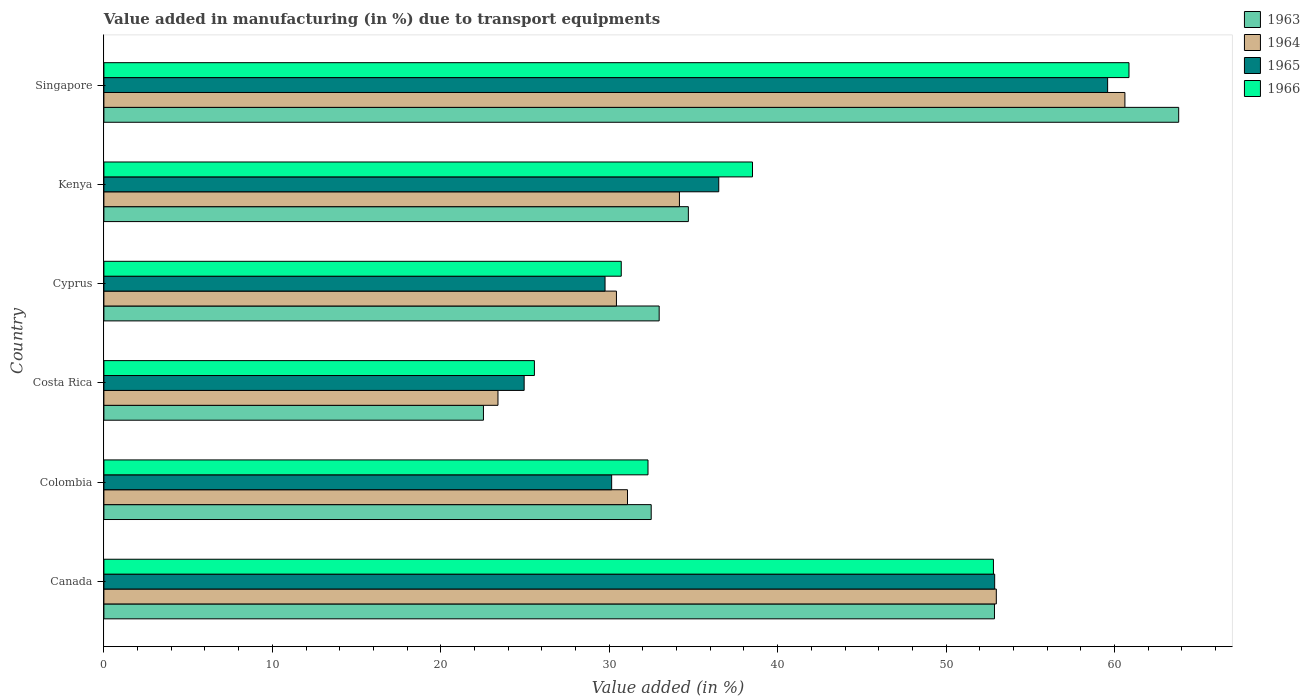How many different coloured bars are there?
Make the answer very short. 4. How many groups of bars are there?
Give a very brief answer. 6. Are the number of bars on each tick of the Y-axis equal?
Make the answer very short. Yes. How many bars are there on the 5th tick from the bottom?
Give a very brief answer. 4. What is the label of the 2nd group of bars from the top?
Your answer should be compact. Kenya. What is the percentage of value added in manufacturing due to transport equipments in 1966 in Singapore?
Ensure brevity in your answer.  60.86. Across all countries, what is the maximum percentage of value added in manufacturing due to transport equipments in 1963?
Your response must be concise. 63.81. Across all countries, what is the minimum percentage of value added in manufacturing due to transport equipments in 1963?
Make the answer very short. 22.53. In which country was the percentage of value added in manufacturing due to transport equipments in 1963 maximum?
Offer a very short reply. Singapore. In which country was the percentage of value added in manufacturing due to transport equipments in 1963 minimum?
Provide a short and direct response. Costa Rica. What is the total percentage of value added in manufacturing due to transport equipments in 1966 in the graph?
Provide a succinct answer. 240.76. What is the difference between the percentage of value added in manufacturing due to transport equipments in 1966 in Costa Rica and that in Cyprus?
Your response must be concise. -5.16. What is the difference between the percentage of value added in manufacturing due to transport equipments in 1964 in Singapore and the percentage of value added in manufacturing due to transport equipments in 1965 in Canada?
Offer a terse response. 7.73. What is the average percentage of value added in manufacturing due to transport equipments in 1963 per country?
Your response must be concise. 39.9. What is the difference between the percentage of value added in manufacturing due to transport equipments in 1963 and percentage of value added in manufacturing due to transport equipments in 1965 in Singapore?
Keep it short and to the point. 4.22. What is the ratio of the percentage of value added in manufacturing due to transport equipments in 1966 in Colombia to that in Cyprus?
Your answer should be very brief. 1.05. Is the percentage of value added in manufacturing due to transport equipments in 1965 in Costa Rica less than that in Cyprus?
Offer a terse response. Yes. Is the difference between the percentage of value added in manufacturing due to transport equipments in 1963 in Canada and Colombia greater than the difference between the percentage of value added in manufacturing due to transport equipments in 1965 in Canada and Colombia?
Your response must be concise. No. What is the difference between the highest and the second highest percentage of value added in manufacturing due to transport equipments in 1966?
Offer a very short reply. 8.05. What is the difference between the highest and the lowest percentage of value added in manufacturing due to transport equipments in 1963?
Ensure brevity in your answer.  41.28. What does the 3rd bar from the top in Singapore represents?
Your answer should be very brief. 1964. What does the 1st bar from the bottom in Singapore represents?
Keep it short and to the point. 1963. What is the difference between two consecutive major ticks on the X-axis?
Ensure brevity in your answer.  10. How are the legend labels stacked?
Make the answer very short. Vertical. What is the title of the graph?
Your response must be concise. Value added in manufacturing (in %) due to transport equipments. What is the label or title of the X-axis?
Keep it short and to the point. Value added (in %). What is the label or title of the Y-axis?
Give a very brief answer. Country. What is the Value added (in %) of 1963 in Canada?
Offer a very short reply. 52.87. What is the Value added (in %) of 1964 in Canada?
Offer a very short reply. 52.98. What is the Value added (in %) in 1965 in Canada?
Make the answer very short. 52.89. What is the Value added (in %) in 1966 in Canada?
Provide a short and direct response. 52.81. What is the Value added (in %) in 1963 in Colombia?
Make the answer very short. 32.49. What is the Value added (in %) in 1964 in Colombia?
Provide a succinct answer. 31.09. What is the Value added (in %) in 1965 in Colombia?
Ensure brevity in your answer.  30.15. What is the Value added (in %) in 1966 in Colombia?
Your response must be concise. 32.3. What is the Value added (in %) in 1963 in Costa Rica?
Give a very brief answer. 22.53. What is the Value added (in %) of 1964 in Costa Rica?
Provide a short and direct response. 23.4. What is the Value added (in %) of 1965 in Costa Rica?
Make the answer very short. 24.95. What is the Value added (in %) in 1966 in Costa Rica?
Keep it short and to the point. 25.56. What is the Value added (in %) in 1963 in Cyprus?
Ensure brevity in your answer.  32.97. What is the Value added (in %) in 1964 in Cyprus?
Offer a terse response. 30.43. What is the Value added (in %) in 1965 in Cyprus?
Offer a very short reply. 29.75. What is the Value added (in %) in 1966 in Cyprus?
Your answer should be very brief. 30.72. What is the Value added (in %) in 1963 in Kenya?
Make the answer very short. 34.7. What is the Value added (in %) in 1964 in Kenya?
Provide a succinct answer. 34.17. What is the Value added (in %) in 1965 in Kenya?
Offer a terse response. 36.5. What is the Value added (in %) of 1966 in Kenya?
Make the answer very short. 38.51. What is the Value added (in %) in 1963 in Singapore?
Offer a terse response. 63.81. What is the Value added (in %) of 1964 in Singapore?
Your answer should be very brief. 60.62. What is the Value added (in %) in 1965 in Singapore?
Keep it short and to the point. 59.59. What is the Value added (in %) of 1966 in Singapore?
Ensure brevity in your answer.  60.86. Across all countries, what is the maximum Value added (in %) of 1963?
Your response must be concise. 63.81. Across all countries, what is the maximum Value added (in %) in 1964?
Give a very brief answer. 60.62. Across all countries, what is the maximum Value added (in %) of 1965?
Make the answer very short. 59.59. Across all countries, what is the maximum Value added (in %) of 1966?
Provide a short and direct response. 60.86. Across all countries, what is the minimum Value added (in %) of 1963?
Provide a succinct answer. 22.53. Across all countries, what is the minimum Value added (in %) of 1964?
Your response must be concise. 23.4. Across all countries, what is the minimum Value added (in %) of 1965?
Your answer should be compact. 24.95. Across all countries, what is the minimum Value added (in %) of 1966?
Make the answer very short. 25.56. What is the total Value added (in %) of 1963 in the graph?
Your answer should be compact. 239.38. What is the total Value added (in %) in 1964 in the graph?
Your answer should be compact. 232.68. What is the total Value added (in %) in 1965 in the graph?
Ensure brevity in your answer.  233.83. What is the total Value added (in %) of 1966 in the graph?
Your response must be concise. 240.76. What is the difference between the Value added (in %) in 1963 in Canada and that in Colombia?
Offer a very short reply. 20.38. What is the difference between the Value added (in %) in 1964 in Canada and that in Colombia?
Ensure brevity in your answer.  21.9. What is the difference between the Value added (in %) in 1965 in Canada and that in Colombia?
Your response must be concise. 22.74. What is the difference between the Value added (in %) in 1966 in Canada and that in Colombia?
Give a very brief answer. 20.51. What is the difference between the Value added (in %) in 1963 in Canada and that in Costa Rica?
Make the answer very short. 30.34. What is the difference between the Value added (in %) of 1964 in Canada and that in Costa Rica?
Keep it short and to the point. 29.59. What is the difference between the Value added (in %) of 1965 in Canada and that in Costa Rica?
Offer a very short reply. 27.93. What is the difference between the Value added (in %) in 1966 in Canada and that in Costa Rica?
Offer a very short reply. 27.25. What is the difference between the Value added (in %) in 1963 in Canada and that in Cyprus?
Your answer should be compact. 19.91. What is the difference between the Value added (in %) in 1964 in Canada and that in Cyprus?
Ensure brevity in your answer.  22.55. What is the difference between the Value added (in %) in 1965 in Canada and that in Cyprus?
Your answer should be compact. 23.13. What is the difference between the Value added (in %) of 1966 in Canada and that in Cyprus?
Offer a very short reply. 22.1. What is the difference between the Value added (in %) in 1963 in Canada and that in Kenya?
Offer a very short reply. 18.17. What is the difference between the Value added (in %) in 1964 in Canada and that in Kenya?
Offer a terse response. 18.81. What is the difference between the Value added (in %) in 1965 in Canada and that in Kenya?
Provide a succinct answer. 16.38. What is the difference between the Value added (in %) of 1966 in Canada and that in Kenya?
Your response must be concise. 14.3. What is the difference between the Value added (in %) in 1963 in Canada and that in Singapore?
Offer a terse response. -10.94. What is the difference between the Value added (in %) of 1964 in Canada and that in Singapore?
Your response must be concise. -7.63. What is the difference between the Value added (in %) in 1965 in Canada and that in Singapore?
Your response must be concise. -6.71. What is the difference between the Value added (in %) in 1966 in Canada and that in Singapore?
Keep it short and to the point. -8.05. What is the difference between the Value added (in %) in 1963 in Colombia and that in Costa Rica?
Your response must be concise. 9.96. What is the difference between the Value added (in %) of 1964 in Colombia and that in Costa Rica?
Your answer should be compact. 7.69. What is the difference between the Value added (in %) in 1965 in Colombia and that in Costa Rica?
Keep it short and to the point. 5.2. What is the difference between the Value added (in %) in 1966 in Colombia and that in Costa Rica?
Offer a very short reply. 6.74. What is the difference between the Value added (in %) in 1963 in Colombia and that in Cyprus?
Provide a short and direct response. -0.47. What is the difference between the Value added (in %) of 1964 in Colombia and that in Cyprus?
Your answer should be very brief. 0.66. What is the difference between the Value added (in %) in 1965 in Colombia and that in Cyprus?
Keep it short and to the point. 0.39. What is the difference between the Value added (in %) in 1966 in Colombia and that in Cyprus?
Make the answer very short. 1.59. What is the difference between the Value added (in %) in 1963 in Colombia and that in Kenya?
Keep it short and to the point. -2.21. What is the difference between the Value added (in %) of 1964 in Colombia and that in Kenya?
Give a very brief answer. -3.08. What is the difference between the Value added (in %) in 1965 in Colombia and that in Kenya?
Provide a succinct answer. -6.36. What is the difference between the Value added (in %) in 1966 in Colombia and that in Kenya?
Ensure brevity in your answer.  -6.2. What is the difference between the Value added (in %) of 1963 in Colombia and that in Singapore?
Make the answer very short. -31.32. What is the difference between the Value added (in %) of 1964 in Colombia and that in Singapore?
Your response must be concise. -29.53. What is the difference between the Value added (in %) of 1965 in Colombia and that in Singapore?
Ensure brevity in your answer.  -29.45. What is the difference between the Value added (in %) of 1966 in Colombia and that in Singapore?
Provide a short and direct response. -28.56. What is the difference between the Value added (in %) in 1963 in Costa Rica and that in Cyprus?
Provide a short and direct response. -10.43. What is the difference between the Value added (in %) in 1964 in Costa Rica and that in Cyprus?
Your response must be concise. -7.03. What is the difference between the Value added (in %) in 1965 in Costa Rica and that in Cyprus?
Give a very brief answer. -4.8. What is the difference between the Value added (in %) of 1966 in Costa Rica and that in Cyprus?
Offer a terse response. -5.16. What is the difference between the Value added (in %) in 1963 in Costa Rica and that in Kenya?
Provide a short and direct response. -12.17. What is the difference between the Value added (in %) in 1964 in Costa Rica and that in Kenya?
Provide a short and direct response. -10.77. What is the difference between the Value added (in %) of 1965 in Costa Rica and that in Kenya?
Your answer should be very brief. -11.55. What is the difference between the Value added (in %) in 1966 in Costa Rica and that in Kenya?
Give a very brief answer. -12.95. What is the difference between the Value added (in %) of 1963 in Costa Rica and that in Singapore?
Your answer should be very brief. -41.28. What is the difference between the Value added (in %) in 1964 in Costa Rica and that in Singapore?
Provide a succinct answer. -37.22. What is the difference between the Value added (in %) in 1965 in Costa Rica and that in Singapore?
Offer a very short reply. -34.64. What is the difference between the Value added (in %) in 1966 in Costa Rica and that in Singapore?
Your answer should be very brief. -35.3. What is the difference between the Value added (in %) in 1963 in Cyprus and that in Kenya?
Your response must be concise. -1.73. What is the difference between the Value added (in %) of 1964 in Cyprus and that in Kenya?
Your response must be concise. -3.74. What is the difference between the Value added (in %) of 1965 in Cyprus and that in Kenya?
Your answer should be compact. -6.75. What is the difference between the Value added (in %) in 1966 in Cyprus and that in Kenya?
Ensure brevity in your answer.  -7.79. What is the difference between the Value added (in %) in 1963 in Cyprus and that in Singapore?
Your answer should be very brief. -30.84. What is the difference between the Value added (in %) of 1964 in Cyprus and that in Singapore?
Your answer should be compact. -30.19. What is the difference between the Value added (in %) of 1965 in Cyprus and that in Singapore?
Your answer should be very brief. -29.84. What is the difference between the Value added (in %) in 1966 in Cyprus and that in Singapore?
Offer a very short reply. -30.14. What is the difference between the Value added (in %) of 1963 in Kenya and that in Singapore?
Offer a terse response. -29.11. What is the difference between the Value added (in %) in 1964 in Kenya and that in Singapore?
Make the answer very short. -26.45. What is the difference between the Value added (in %) in 1965 in Kenya and that in Singapore?
Keep it short and to the point. -23.09. What is the difference between the Value added (in %) of 1966 in Kenya and that in Singapore?
Keep it short and to the point. -22.35. What is the difference between the Value added (in %) of 1963 in Canada and the Value added (in %) of 1964 in Colombia?
Provide a short and direct response. 21.79. What is the difference between the Value added (in %) of 1963 in Canada and the Value added (in %) of 1965 in Colombia?
Keep it short and to the point. 22.73. What is the difference between the Value added (in %) in 1963 in Canada and the Value added (in %) in 1966 in Colombia?
Make the answer very short. 20.57. What is the difference between the Value added (in %) in 1964 in Canada and the Value added (in %) in 1965 in Colombia?
Make the answer very short. 22.84. What is the difference between the Value added (in %) in 1964 in Canada and the Value added (in %) in 1966 in Colombia?
Offer a very short reply. 20.68. What is the difference between the Value added (in %) in 1965 in Canada and the Value added (in %) in 1966 in Colombia?
Keep it short and to the point. 20.58. What is the difference between the Value added (in %) of 1963 in Canada and the Value added (in %) of 1964 in Costa Rica?
Your answer should be compact. 29.48. What is the difference between the Value added (in %) in 1963 in Canada and the Value added (in %) in 1965 in Costa Rica?
Make the answer very short. 27.92. What is the difference between the Value added (in %) in 1963 in Canada and the Value added (in %) in 1966 in Costa Rica?
Provide a short and direct response. 27.31. What is the difference between the Value added (in %) in 1964 in Canada and the Value added (in %) in 1965 in Costa Rica?
Your answer should be very brief. 28.03. What is the difference between the Value added (in %) of 1964 in Canada and the Value added (in %) of 1966 in Costa Rica?
Make the answer very short. 27.42. What is the difference between the Value added (in %) in 1965 in Canada and the Value added (in %) in 1966 in Costa Rica?
Offer a terse response. 27.33. What is the difference between the Value added (in %) of 1963 in Canada and the Value added (in %) of 1964 in Cyprus?
Offer a very short reply. 22.44. What is the difference between the Value added (in %) of 1963 in Canada and the Value added (in %) of 1965 in Cyprus?
Your answer should be very brief. 23.12. What is the difference between the Value added (in %) in 1963 in Canada and the Value added (in %) in 1966 in Cyprus?
Give a very brief answer. 22.16. What is the difference between the Value added (in %) in 1964 in Canada and the Value added (in %) in 1965 in Cyprus?
Make the answer very short. 23.23. What is the difference between the Value added (in %) of 1964 in Canada and the Value added (in %) of 1966 in Cyprus?
Make the answer very short. 22.27. What is the difference between the Value added (in %) in 1965 in Canada and the Value added (in %) in 1966 in Cyprus?
Give a very brief answer. 22.17. What is the difference between the Value added (in %) of 1963 in Canada and the Value added (in %) of 1964 in Kenya?
Ensure brevity in your answer.  18.7. What is the difference between the Value added (in %) of 1963 in Canada and the Value added (in %) of 1965 in Kenya?
Provide a succinct answer. 16.37. What is the difference between the Value added (in %) in 1963 in Canada and the Value added (in %) in 1966 in Kenya?
Offer a very short reply. 14.37. What is the difference between the Value added (in %) of 1964 in Canada and the Value added (in %) of 1965 in Kenya?
Make the answer very short. 16.48. What is the difference between the Value added (in %) of 1964 in Canada and the Value added (in %) of 1966 in Kenya?
Provide a succinct answer. 14.47. What is the difference between the Value added (in %) of 1965 in Canada and the Value added (in %) of 1966 in Kenya?
Provide a succinct answer. 14.38. What is the difference between the Value added (in %) in 1963 in Canada and the Value added (in %) in 1964 in Singapore?
Your answer should be compact. -7.74. What is the difference between the Value added (in %) in 1963 in Canada and the Value added (in %) in 1965 in Singapore?
Provide a short and direct response. -6.72. What is the difference between the Value added (in %) of 1963 in Canada and the Value added (in %) of 1966 in Singapore?
Offer a terse response. -7.99. What is the difference between the Value added (in %) of 1964 in Canada and the Value added (in %) of 1965 in Singapore?
Provide a succinct answer. -6.61. What is the difference between the Value added (in %) of 1964 in Canada and the Value added (in %) of 1966 in Singapore?
Give a very brief answer. -7.88. What is the difference between the Value added (in %) of 1965 in Canada and the Value added (in %) of 1966 in Singapore?
Make the answer very short. -7.97. What is the difference between the Value added (in %) in 1963 in Colombia and the Value added (in %) in 1964 in Costa Rica?
Offer a terse response. 9.1. What is the difference between the Value added (in %) of 1963 in Colombia and the Value added (in %) of 1965 in Costa Rica?
Give a very brief answer. 7.54. What is the difference between the Value added (in %) of 1963 in Colombia and the Value added (in %) of 1966 in Costa Rica?
Your answer should be very brief. 6.93. What is the difference between the Value added (in %) in 1964 in Colombia and the Value added (in %) in 1965 in Costa Rica?
Ensure brevity in your answer.  6.14. What is the difference between the Value added (in %) in 1964 in Colombia and the Value added (in %) in 1966 in Costa Rica?
Offer a terse response. 5.53. What is the difference between the Value added (in %) of 1965 in Colombia and the Value added (in %) of 1966 in Costa Rica?
Provide a short and direct response. 4.59. What is the difference between the Value added (in %) of 1963 in Colombia and the Value added (in %) of 1964 in Cyprus?
Your response must be concise. 2.06. What is the difference between the Value added (in %) of 1963 in Colombia and the Value added (in %) of 1965 in Cyprus?
Your response must be concise. 2.74. What is the difference between the Value added (in %) of 1963 in Colombia and the Value added (in %) of 1966 in Cyprus?
Provide a short and direct response. 1.78. What is the difference between the Value added (in %) in 1964 in Colombia and the Value added (in %) in 1965 in Cyprus?
Your response must be concise. 1.33. What is the difference between the Value added (in %) in 1964 in Colombia and the Value added (in %) in 1966 in Cyprus?
Your response must be concise. 0.37. What is the difference between the Value added (in %) of 1965 in Colombia and the Value added (in %) of 1966 in Cyprus?
Keep it short and to the point. -0.57. What is the difference between the Value added (in %) in 1963 in Colombia and the Value added (in %) in 1964 in Kenya?
Provide a short and direct response. -1.68. What is the difference between the Value added (in %) in 1963 in Colombia and the Value added (in %) in 1965 in Kenya?
Provide a short and direct response. -4.01. What is the difference between the Value added (in %) of 1963 in Colombia and the Value added (in %) of 1966 in Kenya?
Your response must be concise. -6.01. What is the difference between the Value added (in %) in 1964 in Colombia and the Value added (in %) in 1965 in Kenya?
Make the answer very short. -5.42. What is the difference between the Value added (in %) of 1964 in Colombia and the Value added (in %) of 1966 in Kenya?
Ensure brevity in your answer.  -7.42. What is the difference between the Value added (in %) in 1965 in Colombia and the Value added (in %) in 1966 in Kenya?
Ensure brevity in your answer.  -8.36. What is the difference between the Value added (in %) in 1963 in Colombia and the Value added (in %) in 1964 in Singapore?
Your response must be concise. -28.12. What is the difference between the Value added (in %) of 1963 in Colombia and the Value added (in %) of 1965 in Singapore?
Ensure brevity in your answer.  -27.1. What is the difference between the Value added (in %) of 1963 in Colombia and the Value added (in %) of 1966 in Singapore?
Your answer should be compact. -28.37. What is the difference between the Value added (in %) in 1964 in Colombia and the Value added (in %) in 1965 in Singapore?
Give a very brief answer. -28.51. What is the difference between the Value added (in %) in 1964 in Colombia and the Value added (in %) in 1966 in Singapore?
Offer a terse response. -29.77. What is the difference between the Value added (in %) in 1965 in Colombia and the Value added (in %) in 1966 in Singapore?
Give a very brief answer. -30.71. What is the difference between the Value added (in %) in 1963 in Costa Rica and the Value added (in %) in 1964 in Cyprus?
Provide a succinct answer. -7.9. What is the difference between the Value added (in %) of 1963 in Costa Rica and the Value added (in %) of 1965 in Cyprus?
Offer a terse response. -7.22. What is the difference between the Value added (in %) in 1963 in Costa Rica and the Value added (in %) in 1966 in Cyprus?
Your answer should be compact. -8.18. What is the difference between the Value added (in %) in 1964 in Costa Rica and the Value added (in %) in 1965 in Cyprus?
Offer a terse response. -6.36. What is the difference between the Value added (in %) of 1964 in Costa Rica and the Value added (in %) of 1966 in Cyprus?
Offer a terse response. -7.32. What is the difference between the Value added (in %) of 1965 in Costa Rica and the Value added (in %) of 1966 in Cyprus?
Make the answer very short. -5.77. What is the difference between the Value added (in %) of 1963 in Costa Rica and the Value added (in %) of 1964 in Kenya?
Offer a very short reply. -11.64. What is the difference between the Value added (in %) in 1963 in Costa Rica and the Value added (in %) in 1965 in Kenya?
Your answer should be very brief. -13.97. What is the difference between the Value added (in %) of 1963 in Costa Rica and the Value added (in %) of 1966 in Kenya?
Provide a succinct answer. -15.97. What is the difference between the Value added (in %) of 1964 in Costa Rica and the Value added (in %) of 1965 in Kenya?
Ensure brevity in your answer.  -13.11. What is the difference between the Value added (in %) of 1964 in Costa Rica and the Value added (in %) of 1966 in Kenya?
Offer a very short reply. -15.11. What is the difference between the Value added (in %) of 1965 in Costa Rica and the Value added (in %) of 1966 in Kenya?
Your answer should be very brief. -13.56. What is the difference between the Value added (in %) of 1963 in Costa Rica and the Value added (in %) of 1964 in Singapore?
Offer a very short reply. -38.08. What is the difference between the Value added (in %) of 1963 in Costa Rica and the Value added (in %) of 1965 in Singapore?
Give a very brief answer. -37.06. What is the difference between the Value added (in %) in 1963 in Costa Rica and the Value added (in %) in 1966 in Singapore?
Ensure brevity in your answer.  -38.33. What is the difference between the Value added (in %) of 1964 in Costa Rica and the Value added (in %) of 1965 in Singapore?
Provide a short and direct response. -36.19. What is the difference between the Value added (in %) in 1964 in Costa Rica and the Value added (in %) in 1966 in Singapore?
Offer a terse response. -37.46. What is the difference between the Value added (in %) of 1965 in Costa Rica and the Value added (in %) of 1966 in Singapore?
Give a very brief answer. -35.91. What is the difference between the Value added (in %) of 1963 in Cyprus and the Value added (in %) of 1964 in Kenya?
Offer a very short reply. -1.2. What is the difference between the Value added (in %) of 1963 in Cyprus and the Value added (in %) of 1965 in Kenya?
Give a very brief answer. -3.54. What is the difference between the Value added (in %) of 1963 in Cyprus and the Value added (in %) of 1966 in Kenya?
Your response must be concise. -5.54. What is the difference between the Value added (in %) in 1964 in Cyprus and the Value added (in %) in 1965 in Kenya?
Keep it short and to the point. -6.07. What is the difference between the Value added (in %) of 1964 in Cyprus and the Value added (in %) of 1966 in Kenya?
Offer a very short reply. -8.08. What is the difference between the Value added (in %) in 1965 in Cyprus and the Value added (in %) in 1966 in Kenya?
Make the answer very short. -8.75. What is the difference between the Value added (in %) in 1963 in Cyprus and the Value added (in %) in 1964 in Singapore?
Provide a succinct answer. -27.65. What is the difference between the Value added (in %) of 1963 in Cyprus and the Value added (in %) of 1965 in Singapore?
Your answer should be very brief. -26.62. What is the difference between the Value added (in %) of 1963 in Cyprus and the Value added (in %) of 1966 in Singapore?
Give a very brief answer. -27.89. What is the difference between the Value added (in %) of 1964 in Cyprus and the Value added (in %) of 1965 in Singapore?
Ensure brevity in your answer.  -29.16. What is the difference between the Value added (in %) in 1964 in Cyprus and the Value added (in %) in 1966 in Singapore?
Offer a very short reply. -30.43. What is the difference between the Value added (in %) of 1965 in Cyprus and the Value added (in %) of 1966 in Singapore?
Provide a succinct answer. -31.11. What is the difference between the Value added (in %) of 1963 in Kenya and the Value added (in %) of 1964 in Singapore?
Your answer should be compact. -25.92. What is the difference between the Value added (in %) of 1963 in Kenya and the Value added (in %) of 1965 in Singapore?
Provide a short and direct response. -24.89. What is the difference between the Value added (in %) of 1963 in Kenya and the Value added (in %) of 1966 in Singapore?
Keep it short and to the point. -26.16. What is the difference between the Value added (in %) in 1964 in Kenya and the Value added (in %) in 1965 in Singapore?
Your response must be concise. -25.42. What is the difference between the Value added (in %) in 1964 in Kenya and the Value added (in %) in 1966 in Singapore?
Your answer should be compact. -26.69. What is the difference between the Value added (in %) of 1965 in Kenya and the Value added (in %) of 1966 in Singapore?
Your response must be concise. -24.36. What is the average Value added (in %) in 1963 per country?
Make the answer very short. 39.9. What is the average Value added (in %) in 1964 per country?
Offer a terse response. 38.78. What is the average Value added (in %) of 1965 per country?
Your answer should be very brief. 38.97. What is the average Value added (in %) of 1966 per country?
Make the answer very short. 40.13. What is the difference between the Value added (in %) in 1963 and Value added (in %) in 1964 in Canada?
Make the answer very short. -0.11. What is the difference between the Value added (in %) of 1963 and Value added (in %) of 1965 in Canada?
Your answer should be compact. -0.01. What is the difference between the Value added (in %) of 1963 and Value added (in %) of 1966 in Canada?
Keep it short and to the point. 0.06. What is the difference between the Value added (in %) in 1964 and Value added (in %) in 1965 in Canada?
Provide a succinct answer. 0.1. What is the difference between the Value added (in %) of 1964 and Value added (in %) of 1966 in Canada?
Your answer should be very brief. 0.17. What is the difference between the Value added (in %) of 1965 and Value added (in %) of 1966 in Canada?
Provide a succinct answer. 0.07. What is the difference between the Value added (in %) of 1963 and Value added (in %) of 1964 in Colombia?
Your answer should be compact. 1.41. What is the difference between the Value added (in %) of 1963 and Value added (in %) of 1965 in Colombia?
Give a very brief answer. 2.35. What is the difference between the Value added (in %) of 1963 and Value added (in %) of 1966 in Colombia?
Give a very brief answer. 0.19. What is the difference between the Value added (in %) in 1964 and Value added (in %) in 1965 in Colombia?
Your response must be concise. 0.94. What is the difference between the Value added (in %) in 1964 and Value added (in %) in 1966 in Colombia?
Give a very brief answer. -1.22. What is the difference between the Value added (in %) in 1965 and Value added (in %) in 1966 in Colombia?
Your response must be concise. -2.16. What is the difference between the Value added (in %) of 1963 and Value added (in %) of 1964 in Costa Rica?
Keep it short and to the point. -0.86. What is the difference between the Value added (in %) of 1963 and Value added (in %) of 1965 in Costa Rica?
Give a very brief answer. -2.42. What is the difference between the Value added (in %) in 1963 and Value added (in %) in 1966 in Costa Rica?
Keep it short and to the point. -3.03. What is the difference between the Value added (in %) of 1964 and Value added (in %) of 1965 in Costa Rica?
Provide a succinct answer. -1.55. What is the difference between the Value added (in %) of 1964 and Value added (in %) of 1966 in Costa Rica?
Provide a short and direct response. -2.16. What is the difference between the Value added (in %) in 1965 and Value added (in %) in 1966 in Costa Rica?
Keep it short and to the point. -0.61. What is the difference between the Value added (in %) in 1963 and Value added (in %) in 1964 in Cyprus?
Your answer should be compact. 2.54. What is the difference between the Value added (in %) in 1963 and Value added (in %) in 1965 in Cyprus?
Keep it short and to the point. 3.21. What is the difference between the Value added (in %) in 1963 and Value added (in %) in 1966 in Cyprus?
Provide a succinct answer. 2.25. What is the difference between the Value added (in %) of 1964 and Value added (in %) of 1965 in Cyprus?
Provide a short and direct response. 0.68. What is the difference between the Value added (in %) of 1964 and Value added (in %) of 1966 in Cyprus?
Offer a very short reply. -0.29. What is the difference between the Value added (in %) of 1965 and Value added (in %) of 1966 in Cyprus?
Offer a very short reply. -0.96. What is the difference between the Value added (in %) of 1963 and Value added (in %) of 1964 in Kenya?
Keep it short and to the point. 0.53. What is the difference between the Value added (in %) in 1963 and Value added (in %) in 1965 in Kenya?
Ensure brevity in your answer.  -1.8. What is the difference between the Value added (in %) in 1963 and Value added (in %) in 1966 in Kenya?
Provide a succinct answer. -3.81. What is the difference between the Value added (in %) of 1964 and Value added (in %) of 1965 in Kenya?
Provide a succinct answer. -2.33. What is the difference between the Value added (in %) of 1964 and Value added (in %) of 1966 in Kenya?
Offer a terse response. -4.34. What is the difference between the Value added (in %) of 1965 and Value added (in %) of 1966 in Kenya?
Make the answer very short. -2. What is the difference between the Value added (in %) of 1963 and Value added (in %) of 1964 in Singapore?
Give a very brief answer. 3.19. What is the difference between the Value added (in %) of 1963 and Value added (in %) of 1965 in Singapore?
Your answer should be compact. 4.22. What is the difference between the Value added (in %) in 1963 and Value added (in %) in 1966 in Singapore?
Your answer should be compact. 2.95. What is the difference between the Value added (in %) of 1964 and Value added (in %) of 1965 in Singapore?
Your answer should be compact. 1.03. What is the difference between the Value added (in %) in 1964 and Value added (in %) in 1966 in Singapore?
Provide a short and direct response. -0.24. What is the difference between the Value added (in %) in 1965 and Value added (in %) in 1966 in Singapore?
Provide a short and direct response. -1.27. What is the ratio of the Value added (in %) of 1963 in Canada to that in Colombia?
Offer a terse response. 1.63. What is the ratio of the Value added (in %) in 1964 in Canada to that in Colombia?
Ensure brevity in your answer.  1.7. What is the ratio of the Value added (in %) of 1965 in Canada to that in Colombia?
Make the answer very short. 1.75. What is the ratio of the Value added (in %) in 1966 in Canada to that in Colombia?
Your response must be concise. 1.63. What is the ratio of the Value added (in %) in 1963 in Canada to that in Costa Rica?
Ensure brevity in your answer.  2.35. What is the ratio of the Value added (in %) in 1964 in Canada to that in Costa Rica?
Keep it short and to the point. 2.26. What is the ratio of the Value added (in %) in 1965 in Canada to that in Costa Rica?
Ensure brevity in your answer.  2.12. What is the ratio of the Value added (in %) of 1966 in Canada to that in Costa Rica?
Make the answer very short. 2.07. What is the ratio of the Value added (in %) in 1963 in Canada to that in Cyprus?
Your response must be concise. 1.6. What is the ratio of the Value added (in %) of 1964 in Canada to that in Cyprus?
Your answer should be compact. 1.74. What is the ratio of the Value added (in %) in 1965 in Canada to that in Cyprus?
Make the answer very short. 1.78. What is the ratio of the Value added (in %) in 1966 in Canada to that in Cyprus?
Offer a very short reply. 1.72. What is the ratio of the Value added (in %) in 1963 in Canada to that in Kenya?
Your answer should be very brief. 1.52. What is the ratio of the Value added (in %) of 1964 in Canada to that in Kenya?
Give a very brief answer. 1.55. What is the ratio of the Value added (in %) of 1965 in Canada to that in Kenya?
Keep it short and to the point. 1.45. What is the ratio of the Value added (in %) of 1966 in Canada to that in Kenya?
Provide a short and direct response. 1.37. What is the ratio of the Value added (in %) of 1963 in Canada to that in Singapore?
Your response must be concise. 0.83. What is the ratio of the Value added (in %) of 1964 in Canada to that in Singapore?
Your response must be concise. 0.87. What is the ratio of the Value added (in %) of 1965 in Canada to that in Singapore?
Your response must be concise. 0.89. What is the ratio of the Value added (in %) in 1966 in Canada to that in Singapore?
Offer a very short reply. 0.87. What is the ratio of the Value added (in %) of 1963 in Colombia to that in Costa Rica?
Offer a very short reply. 1.44. What is the ratio of the Value added (in %) of 1964 in Colombia to that in Costa Rica?
Ensure brevity in your answer.  1.33. What is the ratio of the Value added (in %) in 1965 in Colombia to that in Costa Rica?
Keep it short and to the point. 1.21. What is the ratio of the Value added (in %) in 1966 in Colombia to that in Costa Rica?
Offer a terse response. 1.26. What is the ratio of the Value added (in %) in 1963 in Colombia to that in Cyprus?
Keep it short and to the point. 0.99. What is the ratio of the Value added (in %) of 1964 in Colombia to that in Cyprus?
Your response must be concise. 1.02. What is the ratio of the Value added (in %) in 1965 in Colombia to that in Cyprus?
Provide a short and direct response. 1.01. What is the ratio of the Value added (in %) of 1966 in Colombia to that in Cyprus?
Provide a succinct answer. 1.05. What is the ratio of the Value added (in %) in 1963 in Colombia to that in Kenya?
Ensure brevity in your answer.  0.94. What is the ratio of the Value added (in %) of 1964 in Colombia to that in Kenya?
Your answer should be compact. 0.91. What is the ratio of the Value added (in %) of 1965 in Colombia to that in Kenya?
Offer a terse response. 0.83. What is the ratio of the Value added (in %) of 1966 in Colombia to that in Kenya?
Your answer should be compact. 0.84. What is the ratio of the Value added (in %) in 1963 in Colombia to that in Singapore?
Give a very brief answer. 0.51. What is the ratio of the Value added (in %) of 1964 in Colombia to that in Singapore?
Your response must be concise. 0.51. What is the ratio of the Value added (in %) of 1965 in Colombia to that in Singapore?
Offer a terse response. 0.51. What is the ratio of the Value added (in %) of 1966 in Colombia to that in Singapore?
Provide a succinct answer. 0.53. What is the ratio of the Value added (in %) in 1963 in Costa Rica to that in Cyprus?
Keep it short and to the point. 0.68. What is the ratio of the Value added (in %) of 1964 in Costa Rica to that in Cyprus?
Give a very brief answer. 0.77. What is the ratio of the Value added (in %) of 1965 in Costa Rica to that in Cyprus?
Your answer should be compact. 0.84. What is the ratio of the Value added (in %) in 1966 in Costa Rica to that in Cyprus?
Make the answer very short. 0.83. What is the ratio of the Value added (in %) in 1963 in Costa Rica to that in Kenya?
Offer a terse response. 0.65. What is the ratio of the Value added (in %) of 1964 in Costa Rica to that in Kenya?
Your answer should be very brief. 0.68. What is the ratio of the Value added (in %) in 1965 in Costa Rica to that in Kenya?
Offer a terse response. 0.68. What is the ratio of the Value added (in %) in 1966 in Costa Rica to that in Kenya?
Offer a very short reply. 0.66. What is the ratio of the Value added (in %) of 1963 in Costa Rica to that in Singapore?
Give a very brief answer. 0.35. What is the ratio of the Value added (in %) in 1964 in Costa Rica to that in Singapore?
Offer a very short reply. 0.39. What is the ratio of the Value added (in %) of 1965 in Costa Rica to that in Singapore?
Your response must be concise. 0.42. What is the ratio of the Value added (in %) in 1966 in Costa Rica to that in Singapore?
Your response must be concise. 0.42. What is the ratio of the Value added (in %) in 1963 in Cyprus to that in Kenya?
Your answer should be very brief. 0.95. What is the ratio of the Value added (in %) in 1964 in Cyprus to that in Kenya?
Give a very brief answer. 0.89. What is the ratio of the Value added (in %) in 1965 in Cyprus to that in Kenya?
Your response must be concise. 0.82. What is the ratio of the Value added (in %) in 1966 in Cyprus to that in Kenya?
Offer a very short reply. 0.8. What is the ratio of the Value added (in %) in 1963 in Cyprus to that in Singapore?
Your answer should be compact. 0.52. What is the ratio of the Value added (in %) in 1964 in Cyprus to that in Singapore?
Your answer should be compact. 0.5. What is the ratio of the Value added (in %) of 1965 in Cyprus to that in Singapore?
Give a very brief answer. 0.5. What is the ratio of the Value added (in %) in 1966 in Cyprus to that in Singapore?
Offer a terse response. 0.5. What is the ratio of the Value added (in %) of 1963 in Kenya to that in Singapore?
Offer a very short reply. 0.54. What is the ratio of the Value added (in %) of 1964 in Kenya to that in Singapore?
Make the answer very short. 0.56. What is the ratio of the Value added (in %) of 1965 in Kenya to that in Singapore?
Provide a short and direct response. 0.61. What is the ratio of the Value added (in %) of 1966 in Kenya to that in Singapore?
Offer a very short reply. 0.63. What is the difference between the highest and the second highest Value added (in %) in 1963?
Ensure brevity in your answer.  10.94. What is the difference between the highest and the second highest Value added (in %) of 1964?
Keep it short and to the point. 7.63. What is the difference between the highest and the second highest Value added (in %) in 1965?
Give a very brief answer. 6.71. What is the difference between the highest and the second highest Value added (in %) in 1966?
Provide a succinct answer. 8.05. What is the difference between the highest and the lowest Value added (in %) in 1963?
Offer a terse response. 41.28. What is the difference between the highest and the lowest Value added (in %) in 1964?
Provide a short and direct response. 37.22. What is the difference between the highest and the lowest Value added (in %) of 1965?
Provide a succinct answer. 34.64. What is the difference between the highest and the lowest Value added (in %) in 1966?
Your answer should be very brief. 35.3. 